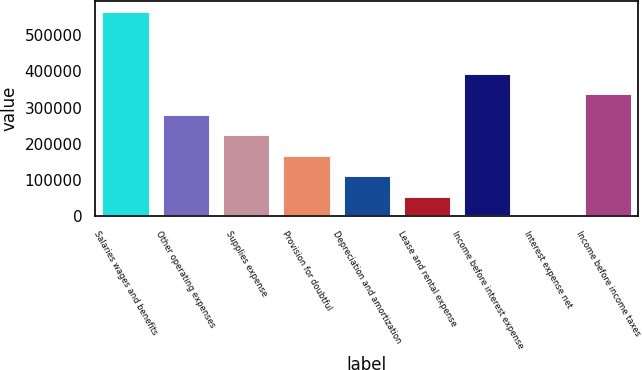<chart> <loc_0><loc_0><loc_500><loc_500><bar_chart><fcel>Salaries wages and benefits<fcel>Other operating expenses<fcel>Supplies expense<fcel>Provision for doubtful<fcel>Depreciation and amortization<fcel>Lease and rental expense<fcel>Income before interest expense<fcel>Interest expense net<fcel>Income before income taxes<nl><fcel>565901<fcel>283118<fcel>226561<fcel>170005<fcel>113448<fcel>56891.6<fcel>396231<fcel>335<fcel>339675<nl></chart> 